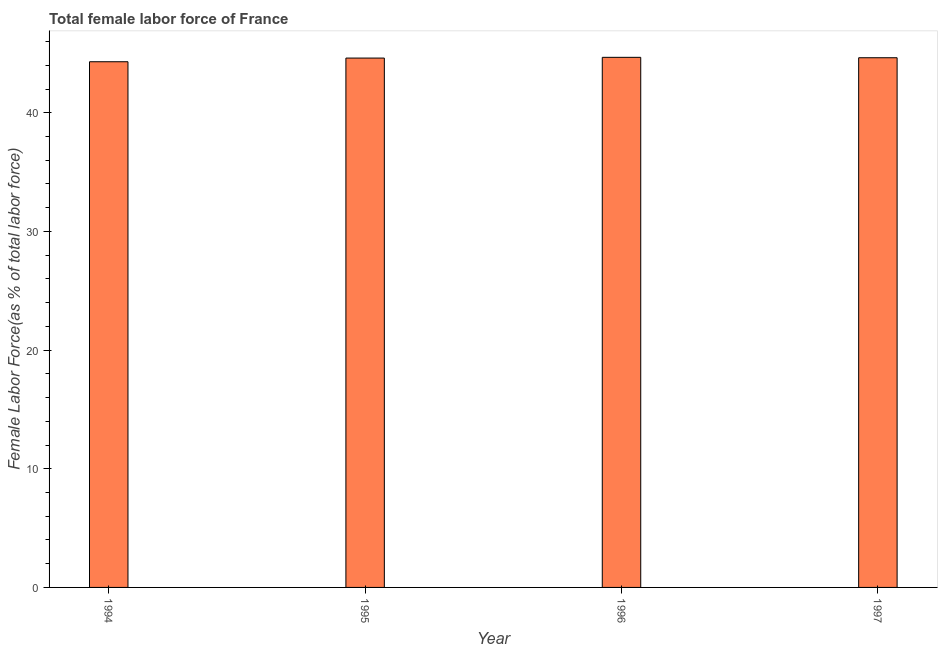What is the title of the graph?
Your response must be concise. Total female labor force of France. What is the label or title of the Y-axis?
Provide a short and direct response. Female Labor Force(as % of total labor force). What is the total female labor force in 1996?
Your response must be concise. 44.67. Across all years, what is the maximum total female labor force?
Ensure brevity in your answer.  44.67. Across all years, what is the minimum total female labor force?
Your answer should be very brief. 44.3. What is the sum of the total female labor force?
Offer a very short reply. 178.23. What is the difference between the total female labor force in 1995 and 1996?
Give a very brief answer. -0.06. What is the average total female labor force per year?
Provide a succinct answer. 44.56. What is the median total female labor force?
Your response must be concise. 44.63. What is the ratio of the total female labor force in 1995 to that in 1997?
Ensure brevity in your answer.  1. What is the difference between the highest and the second highest total female labor force?
Provide a short and direct response. 0.04. Is the sum of the total female labor force in 1996 and 1997 greater than the maximum total female labor force across all years?
Offer a terse response. Yes. What is the difference between the highest and the lowest total female labor force?
Offer a very short reply. 0.37. In how many years, is the total female labor force greater than the average total female labor force taken over all years?
Offer a very short reply. 3. Are all the bars in the graph horizontal?
Give a very brief answer. No. Are the values on the major ticks of Y-axis written in scientific E-notation?
Make the answer very short. No. What is the Female Labor Force(as % of total labor force) in 1994?
Make the answer very short. 44.3. What is the Female Labor Force(as % of total labor force) of 1995?
Offer a very short reply. 44.61. What is the Female Labor Force(as % of total labor force) in 1996?
Provide a short and direct response. 44.67. What is the Female Labor Force(as % of total labor force) of 1997?
Provide a succinct answer. 44.64. What is the difference between the Female Labor Force(as % of total labor force) in 1994 and 1995?
Make the answer very short. -0.31. What is the difference between the Female Labor Force(as % of total labor force) in 1994 and 1996?
Your response must be concise. -0.37. What is the difference between the Female Labor Force(as % of total labor force) in 1994 and 1997?
Offer a very short reply. -0.34. What is the difference between the Female Labor Force(as % of total labor force) in 1995 and 1996?
Offer a terse response. -0.06. What is the difference between the Female Labor Force(as % of total labor force) in 1995 and 1997?
Provide a succinct answer. -0.03. What is the difference between the Female Labor Force(as % of total labor force) in 1996 and 1997?
Your answer should be compact. 0.03. What is the ratio of the Female Labor Force(as % of total labor force) in 1994 to that in 1995?
Your response must be concise. 0.99. What is the ratio of the Female Labor Force(as % of total labor force) in 1994 to that in 1996?
Your answer should be very brief. 0.99. What is the ratio of the Female Labor Force(as % of total labor force) in 1994 to that in 1997?
Offer a very short reply. 0.99. What is the ratio of the Female Labor Force(as % of total labor force) in 1995 to that in 1996?
Offer a terse response. 1. 